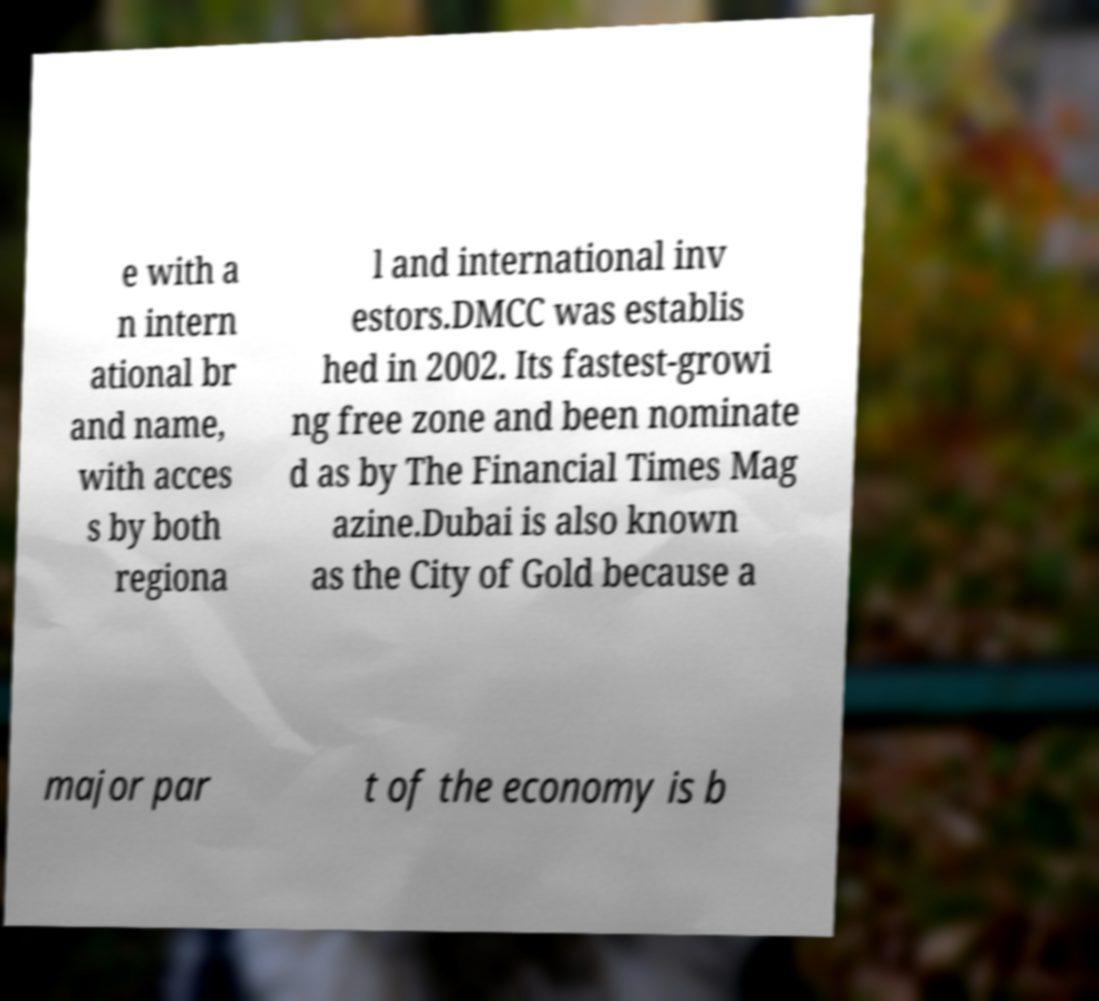For documentation purposes, I need the text within this image transcribed. Could you provide that? e with a n intern ational br and name, with acces s by both regiona l and international inv estors.DMCC was establis hed in 2002. Its fastest-growi ng free zone and been nominate d as by The Financial Times Mag azine.Dubai is also known as the City of Gold because a major par t of the economy is b 